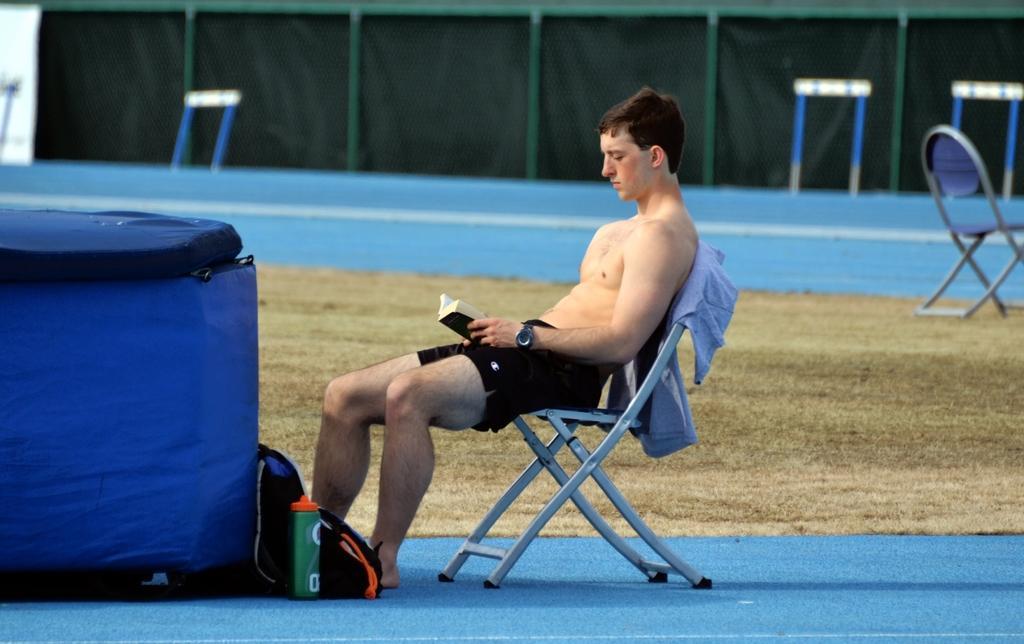In one or two sentences, can you explain what this image depicts? In this image there is a man sitting on the chair, he is holding a book and reading, there is a cloth on the chair, there is ground towards the bottom of the image, there is a bottle on the ground, there is a bag on the ground, there is an object towards the left of the image, there is grass, there are objects on the ground, there is a fence towards the top of the image, there is an object towards the left of the image, there is a cloth behind the fence. 